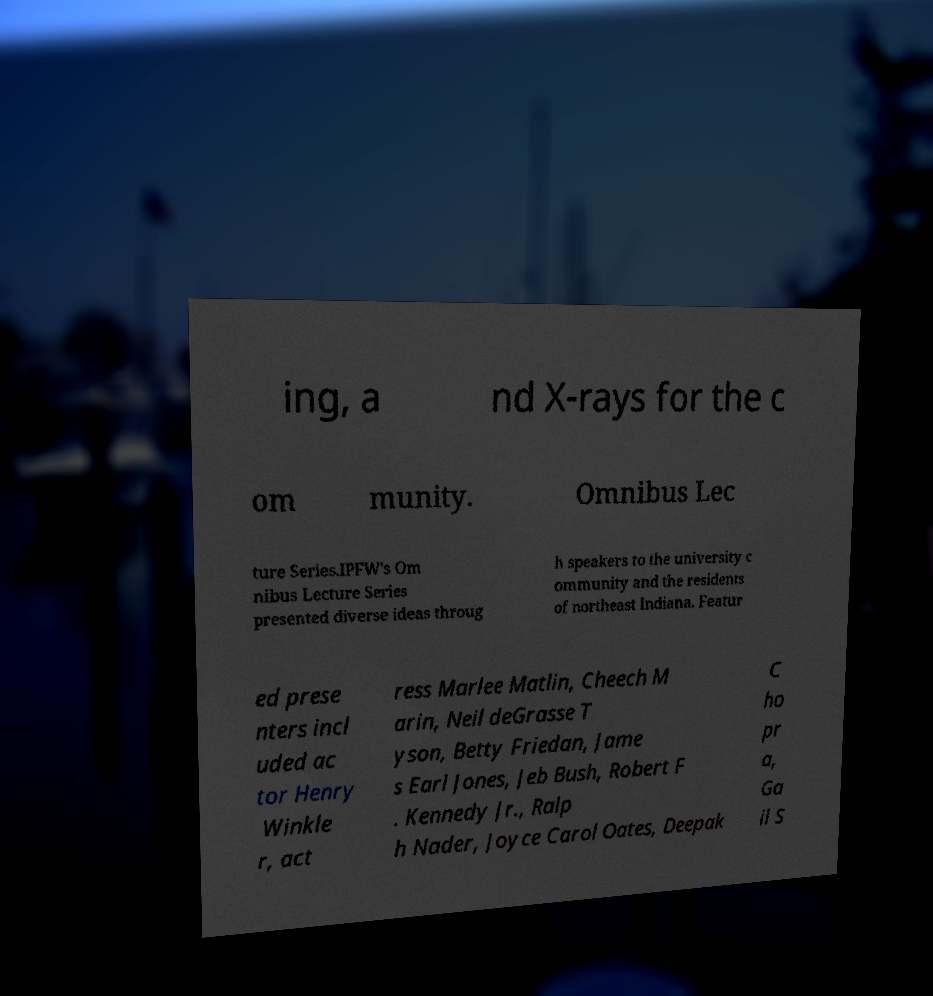I need the written content from this picture converted into text. Can you do that? ing, a nd X-rays for the c om munity. Omnibus Lec ture Series.IPFW's Om nibus Lecture Series presented diverse ideas throug h speakers to the university c ommunity and the residents of northeast Indiana. Featur ed prese nters incl uded ac tor Henry Winkle r, act ress Marlee Matlin, Cheech M arin, Neil deGrasse T yson, Betty Friedan, Jame s Earl Jones, Jeb Bush, Robert F . Kennedy Jr., Ralp h Nader, Joyce Carol Oates, Deepak C ho pr a, Ga il S 